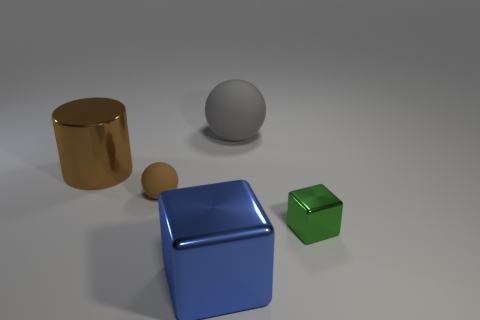Add 4 green shiny cylinders. How many objects exist? 9 Subtract all gray spheres. How many spheres are left? 1 Subtract all balls. How many objects are left? 3 Subtract all purple balls. How many blue cylinders are left? 0 Subtract all small balls. Subtract all large blocks. How many objects are left? 3 Add 4 big gray matte objects. How many big gray matte objects are left? 5 Add 4 gray matte objects. How many gray matte objects exist? 5 Subtract 0 cyan cubes. How many objects are left? 5 Subtract 2 spheres. How many spheres are left? 0 Subtract all purple cubes. Subtract all cyan cylinders. How many cubes are left? 2 